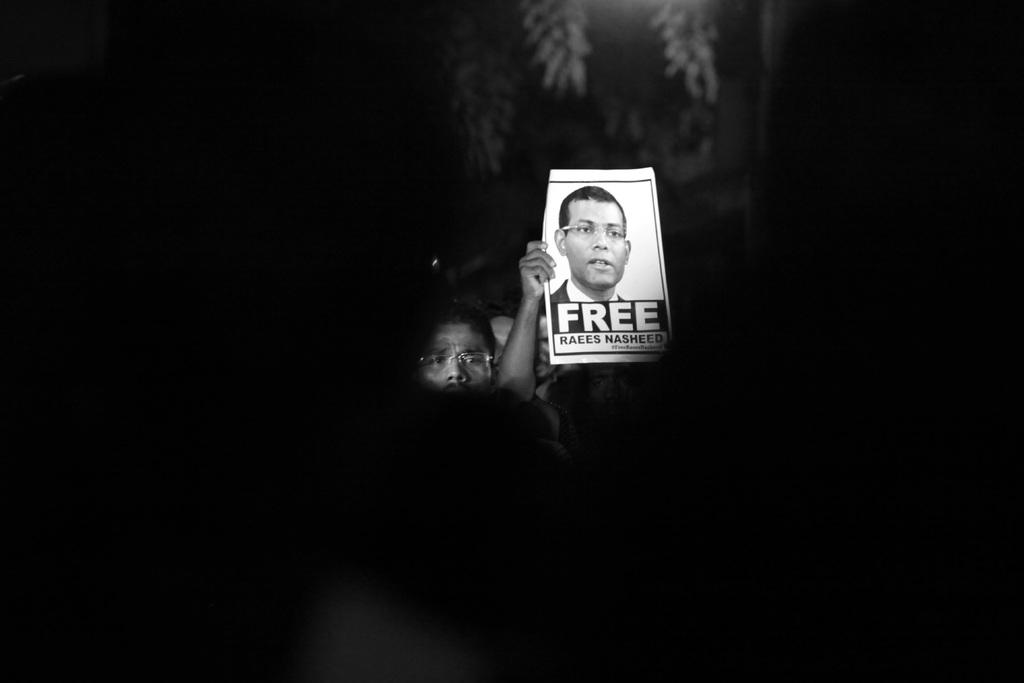What is the overall lighting condition in the image? The image is dark. What is the person in the image holding? The person is holding a poster in the image. What is depicted on the poster? The poster contains a person's face. Are there any words or letters on the poster? Yes, the poster has text on it. Can you tell me the grade of the fog in the image? There is no fog present in the image, so it is not possible to determine its grade. 